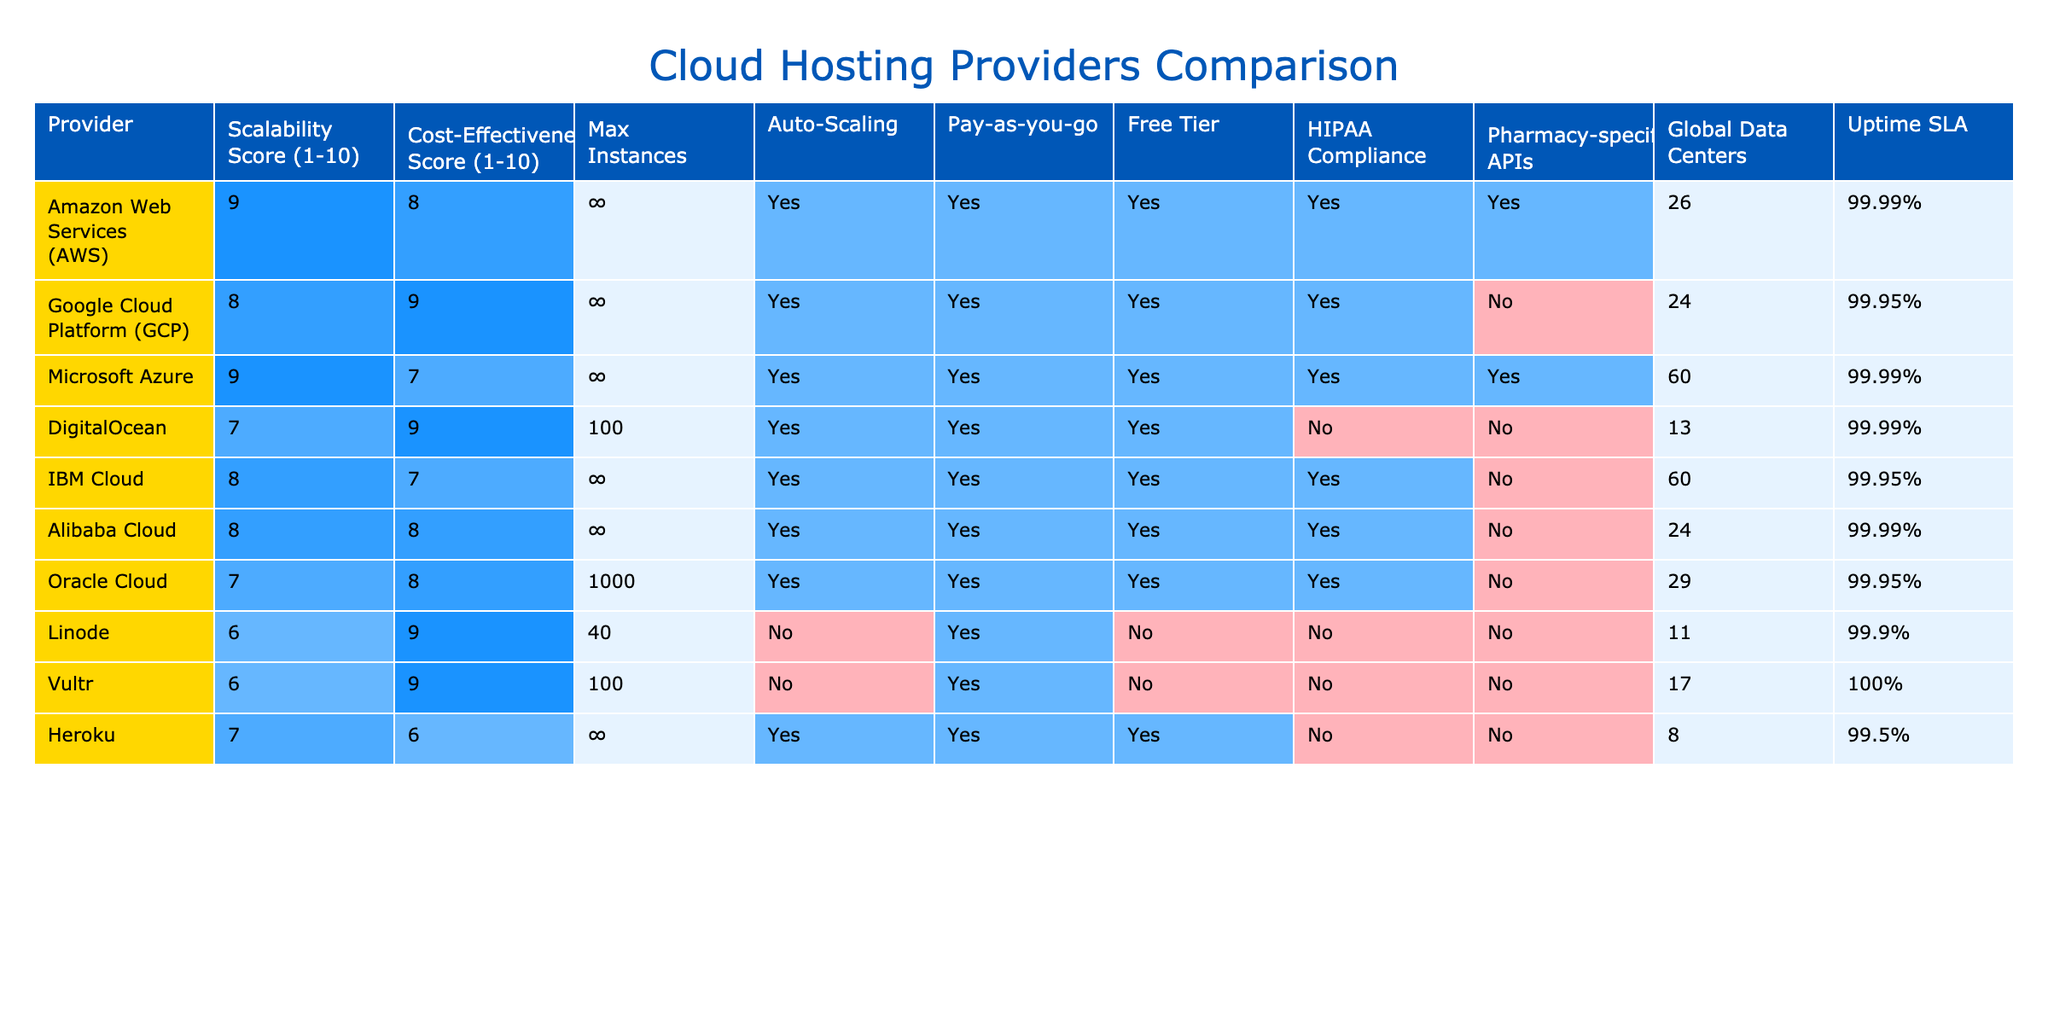What is the maximum number of instances provided by AWS and Azure? AWS offers unlimited instances, while Azure also offers unlimited instances. Thus, both AWS and Azure have the same maximum number of instances, which is ∞ for both.
Answer: ∞ for both Which provider has the highest scalability score? AWS and Azure both have the highest scalability score of 9. However, since the question asks for the single highest, the answer would take the first one listed, which is AWS.
Answer: AWS Is there a provider that offers HIPAA compliance and pharmacy-specific APIs? Looking at the table, AWS, Azure, and IBM Cloud all have HIPAA compliance, but only AWS and Azure have pharmacy-specific APIs. Thus, the answer is yes; AWS and Azure meet both criteria.
Answer: Yes, AWS and Azure What is the average cost-effectiveness score of all providers listed? To calculate the average cost-effectiveness score, we sum the scores: (8 + 9 + 7 + 9 + 7 + 8 + 8 + 9 + 6 + 6 + 6) = 78. There are 11 providers, so the average is 78/11 ≈ 7.09.
Answer: Approximately 7.09 Which provider has the lowest uptime SLA, and what is the value? Linode has the lowest uptime SLA listed at 99.9%. It can be found by scanning the Uptime SLA column and identifying the minimum value.
Answer: 99.9% How many providers have both auto-scaling and pay-as-you-go features? Reviewing the table, six providers (AWS, GCP, Azure, DigitalOcean, IBM Cloud, and Oracle Cloud) have both auto-scaling and pay-as-you-go features.
Answer: Six providers What is the difference in cost-effectiveness scores between DigitalOcean and Heroku? DigitalOcean has a cost-effectiveness score of 9, while Heroku has a score of 6. The difference is calculated by subtracting Heroku's score from DigitalOcean's: 9 - 6 = 3.
Answer: 3 Which provider has a global data center count less than 20? By examining the global data centers column, Linode (11) and Vultr (17) both have counts under 20. However, they are below the threshold of 20 instances listed.
Answer: Linode and Vultr 